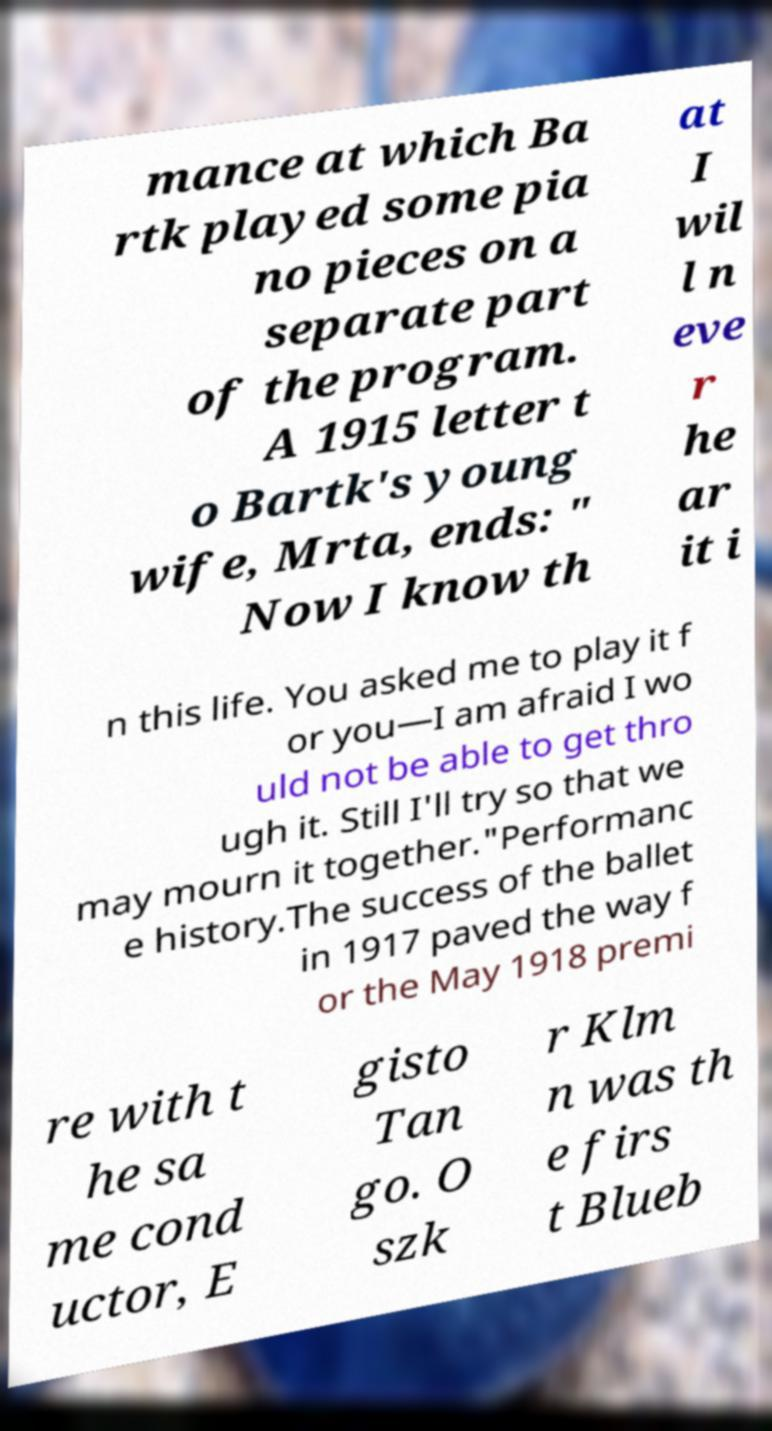Can you accurately transcribe the text from the provided image for me? mance at which Ba rtk played some pia no pieces on a separate part of the program. A 1915 letter t o Bartk's young wife, Mrta, ends: " Now I know th at I wil l n eve r he ar it i n this life. You asked me to play it f or you—I am afraid I wo uld not be able to get thro ugh it. Still I'll try so that we may mourn it together."Performanc e history.The success of the ballet in 1917 paved the way f or the May 1918 premi re with t he sa me cond uctor, E gisto Tan go. O szk r Klm n was th e firs t Blueb 